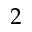<formula> <loc_0><loc_0><loc_500><loc_500>2</formula> 